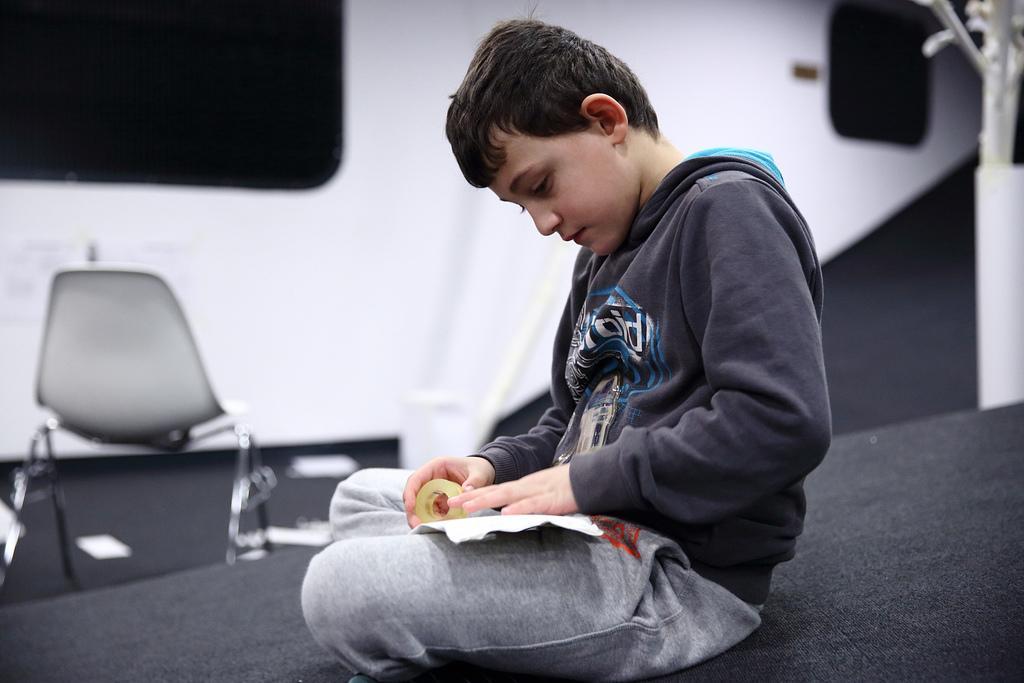Can you describe this image briefly? In this image we can see a boy is holding something in the hands. In the back there is a chair. And the boy is sitting. 